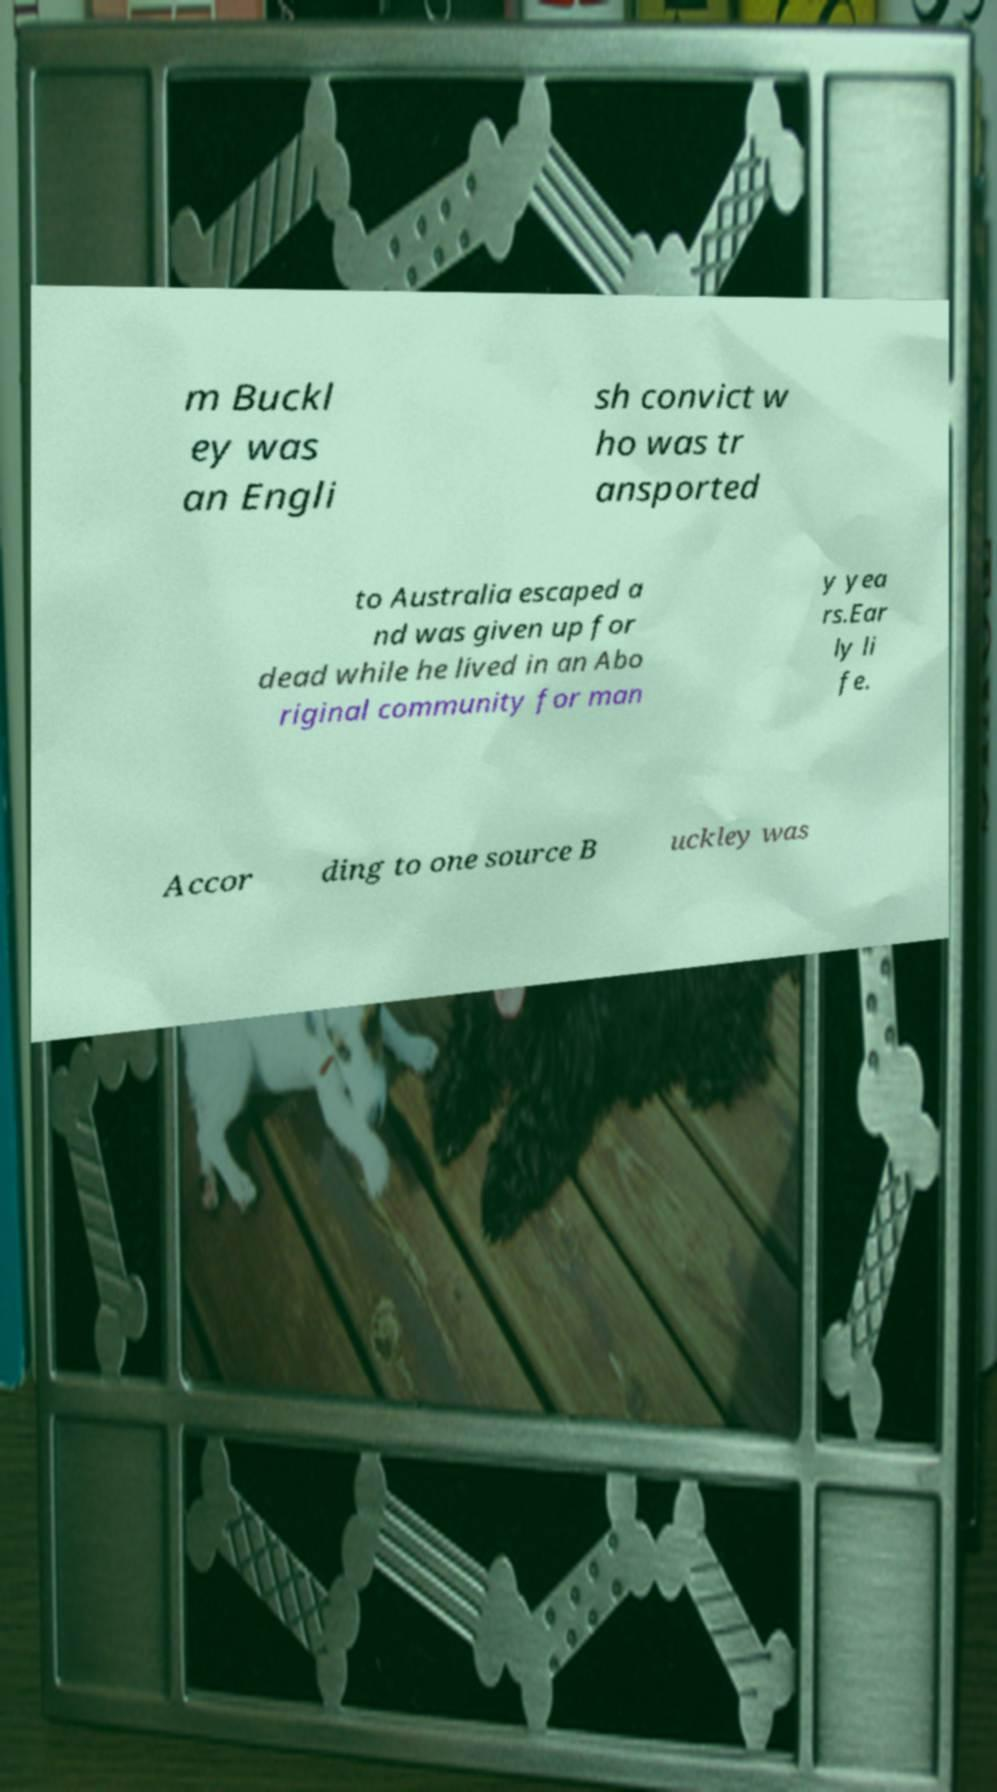There's text embedded in this image that I need extracted. Can you transcribe it verbatim? m Buckl ey was an Engli sh convict w ho was tr ansported to Australia escaped a nd was given up for dead while he lived in an Abo riginal community for man y yea rs.Ear ly li fe. Accor ding to one source B uckley was 